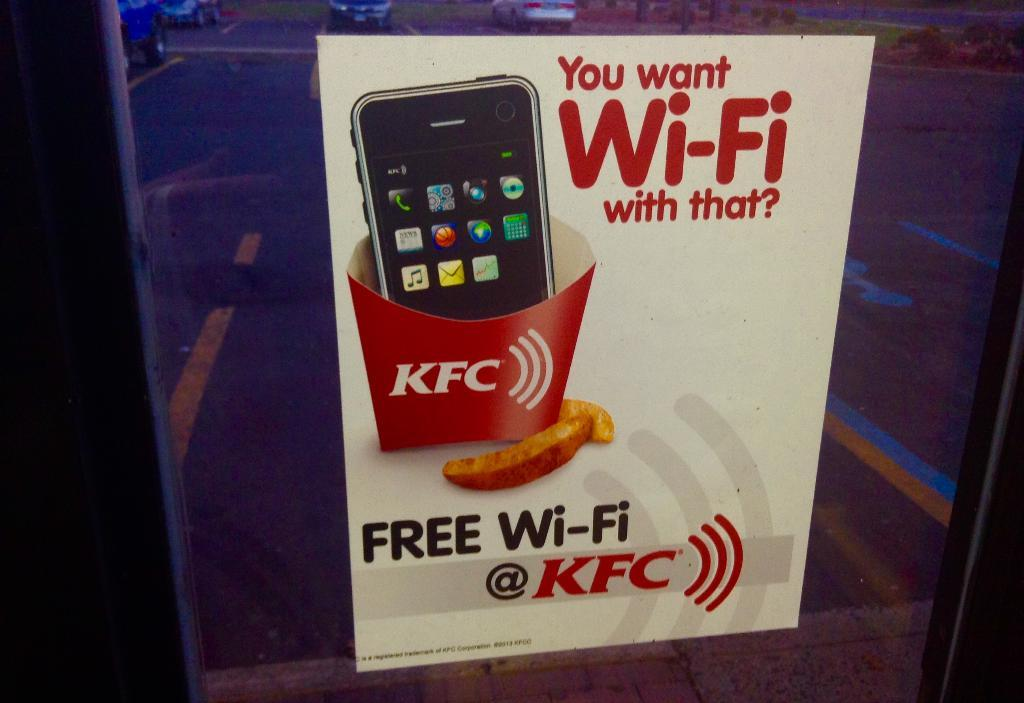<image>
Give a short and clear explanation of the subsequent image. a KFC box that has a phone on it 